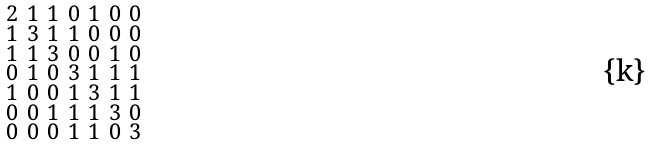Convert formula to latex. <formula><loc_0><loc_0><loc_500><loc_500>\begin{smallmatrix} 2 & 1 & 1 & 0 & 1 & 0 & 0 \\ 1 & 3 & 1 & 1 & 0 & 0 & 0 \\ 1 & 1 & 3 & 0 & 0 & 1 & 0 \\ 0 & 1 & 0 & 3 & 1 & 1 & 1 \\ 1 & 0 & 0 & 1 & 3 & 1 & 1 \\ 0 & 0 & 1 & 1 & 1 & 3 & 0 \\ 0 & 0 & 0 & 1 & 1 & 0 & 3 \end{smallmatrix}</formula> 